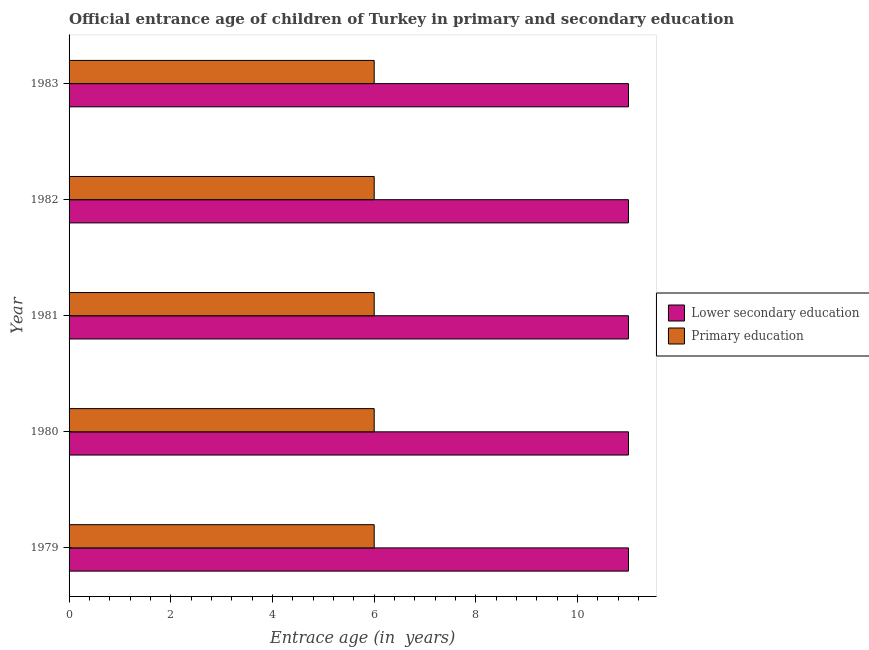How many groups of bars are there?
Your answer should be very brief. 5. Are the number of bars per tick equal to the number of legend labels?
Make the answer very short. Yes. Are the number of bars on each tick of the Y-axis equal?
Provide a short and direct response. Yes. How many bars are there on the 2nd tick from the top?
Offer a terse response. 2. What is the label of the 2nd group of bars from the top?
Provide a succinct answer. 1982. Across all years, what is the minimum entrance age of children in lower secondary education?
Offer a very short reply. 11. In which year was the entrance age of chiildren in primary education maximum?
Your response must be concise. 1979. In which year was the entrance age of chiildren in primary education minimum?
Offer a very short reply. 1979. What is the total entrance age of children in lower secondary education in the graph?
Ensure brevity in your answer.  55. What is the difference between the entrance age of children in lower secondary education in 1981 and the entrance age of chiildren in primary education in 1980?
Offer a terse response. 5. In the year 1982, what is the difference between the entrance age of children in lower secondary education and entrance age of chiildren in primary education?
Your answer should be very brief. 5. In how many years, is the entrance age of chiildren in primary education greater than 5.2 years?
Your answer should be compact. 5. What is the ratio of the entrance age of children in lower secondary education in 1981 to that in 1983?
Keep it short and to the point. 1. What is the difference between the highest and the lowest entrance age of children in lower secondary education?
Make the answer very short. 0. In how many years, is the entrance age of chiildren in primary education greater than the average entrance age of chiildren in primary education taken over all years?
Make the answer very short. 0. What does the 1st bar from the top in 1980 represents?
Provide a succinct answer. Primary education. What does the 2nd bar from the bottom in 1980 represents?
Ensure brevity in your answer.  Primary education. How many bars are there?
Offer a terse response. 10. How many years are there in the graph?
Your answer should be compact. 5. Are the values on the major ticks of X-axis written in scientific E-notation?
Your answer should be compact. No. Does the graph contain any zero values?
Your answer should be compact. No. Does the graph contain grids?
Your response must be concise. No. How are the legend labels stacked?
Your answer should be very brief. Vertical. What is the title of the graph?
Your answer should be compact. Official entrance age of children of Turkey in primary and secondary education. What is the label or title of the X-axis?
Give a very brief answer. Entrace age (in  years). What is the Entrace age (in  years) of Lower secondary education in 1980?
Make the answer very short. 11. What is the Entrace age (in  years) of Primary education in 1981?
Offer a very short reply. 6. What is the Entrace age (in  years) of Lower secondary education in 1982?
Offer a very short reply. 11. What is the Entrace age (in  years) in Primary education in 1982?
Ensure brevity in your answer.  6. What is the Entrace age (in  years) in Lower secondary education in 1983?
Give a very brief answer. 11. What is the Entrace age (in  years) in Primary education in 1983?
Make the answer very short. 6. Across all years, what is the maximum Entrace age (in  years) of Lower secondary education?
Your answer should be compact. 11. Across all years, what is the maximum Entrace age (in  years) of Primary education?
Offer a terse response. 6. Across all years, what is the minimum Entrace age (in  years) in Lower secondary education?
Your response must be concise. 11. What is the total Entrace age (in  years) of Primary education in the graph?
Provide a short and direct response. 30. What is the difference between the Entrace age (in  years) in Lower secondary education in 1979 and that in 1980?
Your answer should be compact. 0. What is the difference between the Entrace age (in  years) in Primary education in 1979 and that in 1980?
Provide a short and direct response. 0. What is the difference between the Entrace age (in  years) in Primary education in 1979 and that in 1981?
Offer a terse response. 0. What is the difference between the Entrace age (in  years) in Lower secondary education in 1979 and that in 1982?
Keep it short and to the point. 0. What is the difference between the Entrace age (in  years) in Primary education in 1979 and that in 1982?
Provide a succinct answer. 0. What is the difference between the Entrace age (in  years) in Lower secondary education in 1980 and that in 1981?
Offer a very short reply. 0. What is the difference between the Entrace age (in  years) of Primary education in 1980 and that in 1981?
Your response must be concise. 0. What is the difference between the Entrace age (in  years) of Lower secondary education in 1980 and that in 1982?
Keep it short and to the point. 0. What is the difference between the Entrace age (in  years) in Primary education in 1980 and that in 1983?
Provide a short and direct response. 0. What is the difference between the Entrace age (in  years) in Primary education in 1981 and that in 1982?
Your response must be concise. 0. What is the difference between the Entrace age (in  years) of Lower secondary education in 1981 and that in 1983?
Provide a short and direct response. 0. What is the difference between the Entrace age (in  years) in Primary education in 1981 and that in 1983?
Ensure brevity in your answer.  0. What is the difference between the Entrace age (in  years) of Lower secondary education in 1982 and that in 1983?
Keep it short and to the point. 0. What is the difference between the Entrace age (in  years) in Lower secondary education in 1979 and the Entrace age (in  years) in Primary education in 1980?
Provide a short and direct response. 5. What is the difference between the Entrace age (in  years) in Lower secondary education in 1979 and the Entrace age (in  years) in Primary education in 1982?
Your answer should be compact. 5. What is the difference between the Entrace age (in  years) of Lower secondary education in 1980 and the Entrace age (in  years) of Primary education in 1981?
Provide a succinct answer. 5. What is the difference between the Entrace age (in  years) of Lower secondary education in 1980 and the Entrace age (in  years) of Primary education in 1982?
Keep it short and to the point. 5. What is the difference between the Entrace age (in  years) in Lower secondary education in 1981 and the Entrace age (in  years) in Primary education in 1983?
Make the answer very short. 5. What is the difference between the Entrace age (in  years) in Lower secondary education in 1982 and the Entrace age (in  years) in Primary education in 1983?
Provide a short and direct response. 5. What is the average Entrace age (in  years) in Lower secondary education per year?
Keep it short and to the point. 11. What is the average Entrace age (in  years) of Primary education per year?
Provide a succinct answer. 6. In the year 1980, what is the difference between the Entrace age (in  years) in Lower secondary education and Entrace age (in  years) in Primary education?
Your answer should be compact. 5. In the year 1981, what is the difference between the Entrace age (in  years) in Lower secondary education and Entrace age (in  years) in Primary education?
Provide a succinct answer. 5. In the year 1982, what is the difference between the Entrace age (in  years) in Lower secondary education and Entrace age (in  years) in Primary education?
Keep it short and to the point. 5. In the year 1983, what is the difference between the Entrace age (in  years) of Lower secondary education and Entrace age (in  years) of Primary education?
Make the answer very short. 5. What is the ratio of the Entrace age (in  years) in Lower secondary education in 1979 to that in 1980?
Your answer should be very brief. 1. What is the ratio of the Entrace age (in  years) of Primary education in 1979 to that in 1980?
Offer a very short reply. 1. What is the ratio of the Entrace age (in  years) of Primary education in 1979 to that in 1981?
Offer a terse response. 1. What is the ratio of the Entrace age (in  years) in Lower secondary education in 1979 to that in 1982?
Your response must be concise. 1. What is the ratio of the Entrace age (in  years) in Primary education in 1979 to that in 1982?
Your response must be concise. 1. What is the ratio of the Entrace age (in  years) in Lower secondary education in 1979 to that in 1983?
Make the answer very short. 1. What is the ratio of the Entrace age (in  years) of Primary education in 1979 to that in 1983?
Your response must be concise. 1. What is the ratio of the Entrace age (in  years) in Lower secondary education in 1980 to that in 1981?
Your response must be concise. 1. What is the ratio of the Entrace age (in  years) of Lower secondary education in 1980 to that in 1982?
Your answer should be very brief. 1. What is the ratio of the Entrace age (in  years) in Lower secondary education in 1980 to that in 1983?
Keep it short and to the point. 1. What is the ratio of the Entrace age (in  years) in Primary education in 1980 to that in 1983?
Your answer should be compact. 1. What is the ratio of the Entrace age (in  years) in Primary education in 1981 to that in 1983?
Offer a very short reply. 1. What is the ratio of the Entrace age (in  years) in Lower secondary education in 1982 to that in 1983?
Keep it short and to the point. 1. What is the ratio of the Entrace age (in  years) in Primary education in 1982 to that in 1983?
Make the answer very short. 1. 